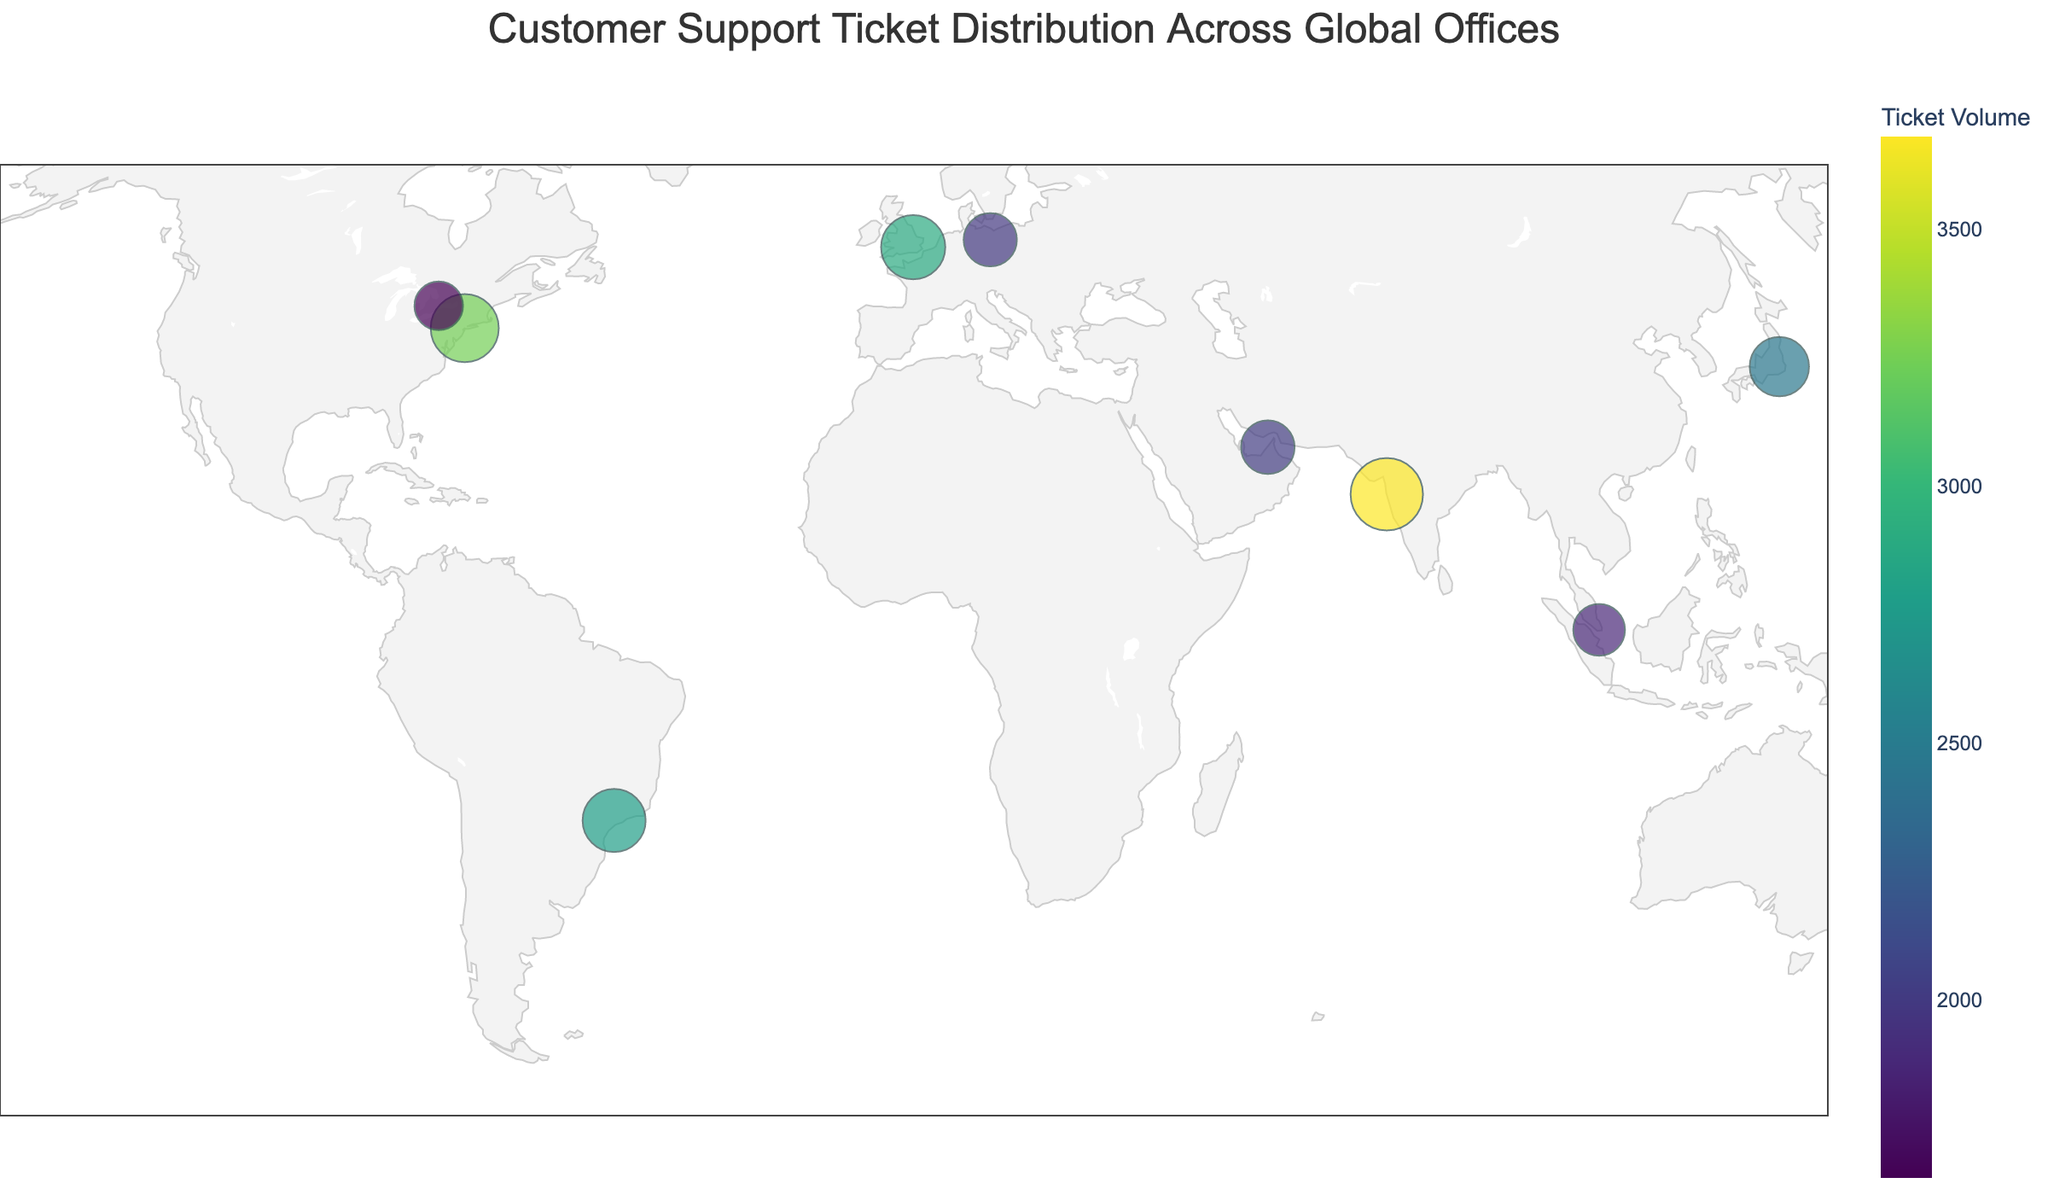What is the title of the figure? The title is located at the top of the figure and outlines the main focus of the plot.
Answer: Customer Support Ticket Distribution Across Global Offices Which office has the highest ticket volume? By looking at the size and color saturation of the data points, the largest circle with the darkest color represents the highest ticket volume.
Answer: Mumbai Which two offices have nearly the same ticket volume? By comparing the sizes and colors of circles, identify pairs of circles that are closely similar. London's and São Paulo's circles are almost the same size and color.
Answer: London and São Paulo What is the ticket volume for the Toronto office? Locate Toronto on the map and refer to the size of its circle. The hover label could also provide this detail.
Answer: 1654 Which continent has the highest number of offices? Count the number of circles on each continent. Europe has London and Berlin, making it the continent with the highest number of offices.
Answer: Europe How does the ticket volume in Sydney compare to that in New York? Compare the size and color of the Sydney and New York circles. New York has a larger and darker circle, indicating higher ticket volume.
Answer: New York has a higher ticket volume than Sydney Which office is located closest to the equator? By observing the latitude positions, determine which data point is closest to the equator (latitude close to 0). Singapore is nearest to the equator.
Answer: Singapore How do the ticket volumes in Berlin and Dubai compare? Compare Berlin's and Dubai's circle sizes and colors. Berlin's volume is 1987, and Dubai's is 2013, indicating Dubai has a slightly higher volume.
Answer: Dubai has a slightly higher ticket volume than Berlin 